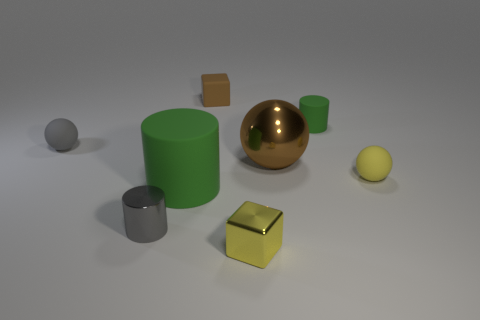There is a big thing that is behind the big matte thing; does it have the same color as the tiny sphere to the right of the brown metal ball?
Provide a succinct answer. No. There is a thing that is on the left side of the rubber block and behind the large brown sphere; what is its shape?
Offer a terse response. Sphere. The rubber cylinder that is the same size as the brown rubber block is what color?
Give a very brief answer. Green. Is there a small block of the same color as the big rubber thing?
Keep it short and to the point. No. There is a green thing that is left of the small yellow metallic block; is its size the same as the shiny thing that is to the left of the yellow shiny thing?
Your answer should be very brief. No. What material is the small thing that is both to the right of the gray rubber thing and on the left side of the small brown matte block?
Make the answer very short. Metal. There is a ball that is the same color as the metal cube; what is its size?
Your answer should be very brief. Small. What number of other objects are there of the same size as the metallic ball?
Your answer should be compact. 1. There is a ball in front of the big brown sphere; what material is it?
Offer a terse response. Rubber. Do the yellow rubber object and the small yellow metal thing have the same shape?
Provide a succinct answer. No. 